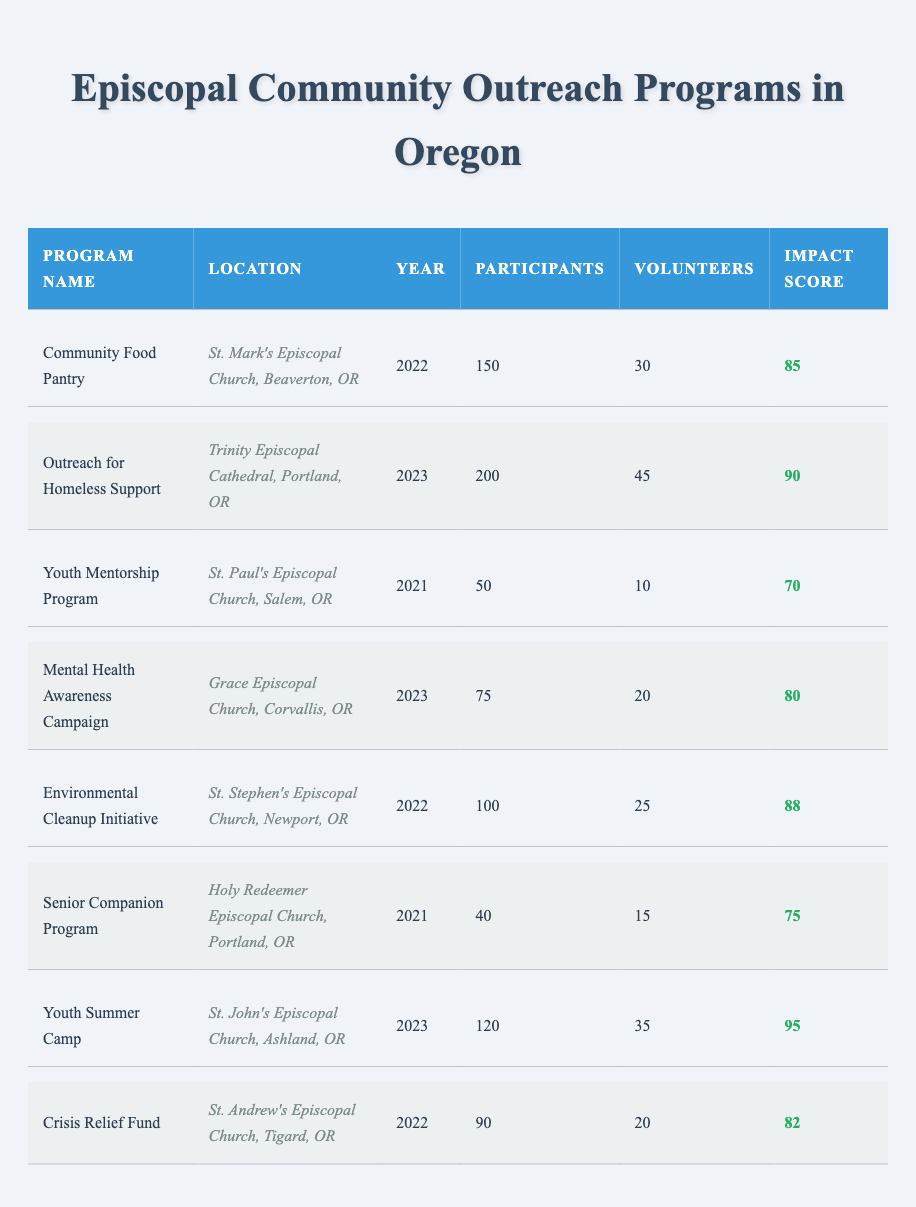What is the program with the highest number of participants? By reviewing the participants' column, I can see that "Outreach for Homeless Support" has 200 participants, which is the highest compared to other programs in the table.
Answer: Outreach for Homeless Support What is the average impact score across all programs? The impact scores are 85, 90, 70, 80, 88, 75, 95, and 82. First, I add them up: 85 + 90 + 70 + 80 + 88 + 75 + 95 + 82 =  665. Then, I divide by the number of programs (8), giving me 665 / 8 = 83.125, which rounds to 83.
Answer: 83 How many volunteers participated in the "Youth Summer Camp"? I can find the entry for "Youth Summer Camp" in the volunteers' column, where it indicates that there were 35 volunteers.
Answer: 35 Did the "Senior Companion Program" have more participants than the "Mental Health Awareness Campaign"? "Senior Companion Program" had 40 participants while "Mental Health Awareness Campaign" had 75 participants. Since 40 is less than 75, the answer is no.
Answer: No What is the total number of participants across all programs in 2022? In 2022, the participants are 150 (Community Food Pantry), 100 (Environmental Cleanup Initiative), and 90 (Crisis Relief Fund). I sum these values: 150 + 100 + 90 = 340.
Answer: 340 Which program had the lowest impact score? The impact scores listed are 85, 90, 70, 80, 88, 75, 95, and 82. The lowest among these is 70 from the "Youth Mentorship Program."
Answer: Youth Mentorship Program How many more volunteers did the "Outreach for Homeless Support" have compared to the "Crisis Relief Fund"? "Outreach for Homeless Support" had 45 volunteers, while "Crisis Relief Fund" had 20 volunteers. The difference is 45 - 20 = 25.
Answer: 25 What percentage of participants in 2023 came from the "Youth Summer Camp"? In 2023, the participants are 200 (Outreach for Homeless Support), 75 (Mental Health Awareness Campaign), and 120 (Youth Summer Camp), which equals 395 in total. The number of participants in the "Youth Summer Camp" is 120. The percentage is (120 / 395) * 100, which is approximately 30.38%.
Answer: 30.38% Which location had the most outreach programs listed? By reviewing the locations, I see that both "Portland, OR" (for Outreach for Homeless Support and Senior Companion Program) have 2 entries, whereas the rest have only 1. Thus, Portland is the location with the most programs.
Answer: Portland, OR 